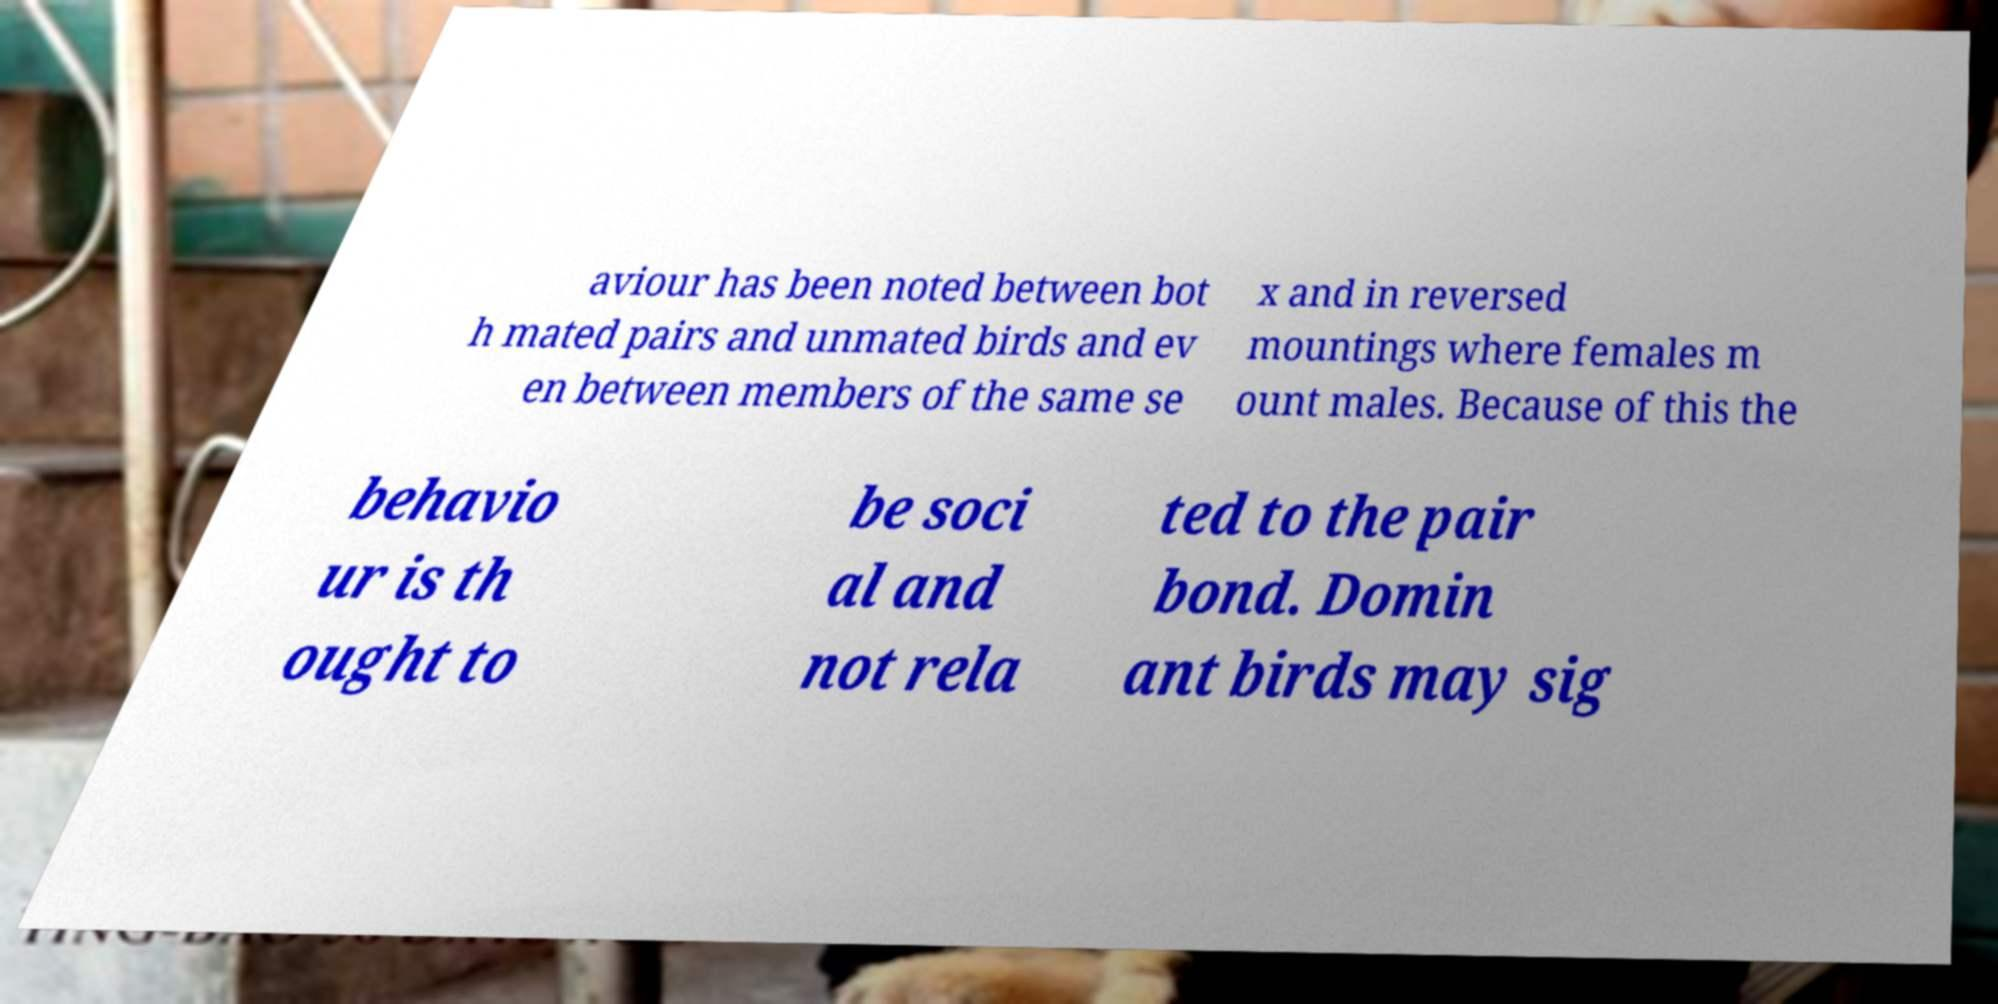Please identify and transcribe the text found in this image. aviour has been noted between bot h mated pairs and unmated birds and ev en between members of the same se x and in reversed mountings where females m ount males. Because of this the behavio ur is th ought to be soci al and not rela ted to the pair bond. Domin ant birds may sig 